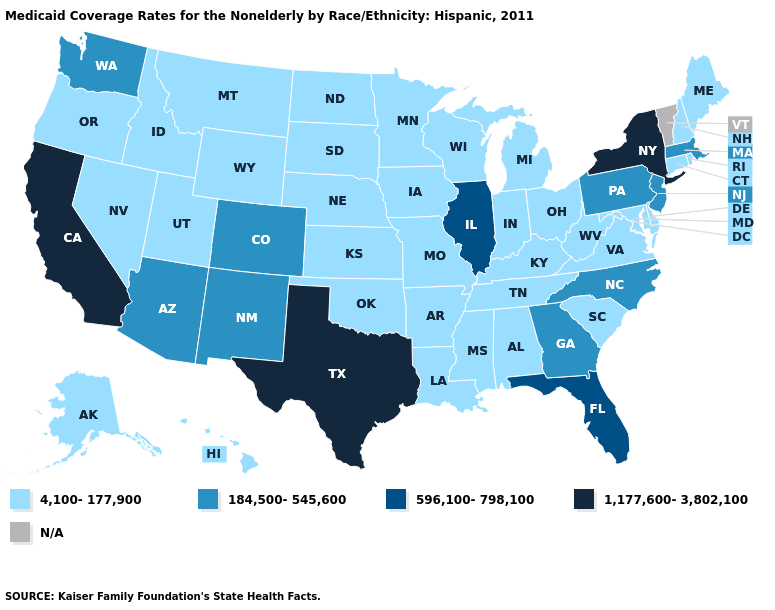Name the states that have a value in the range 4,100-177,900?
Keep it brief. Alabama, Alaska, Arkansas, Connecticut, Delaware, Hawaii, Idaho, Indiana, Iowa, Kansas, Kentucky, Louisiana, Maine, Maryland, Michigan, Minnesota, Mississippi, Missouri, Montana, Nebraska, Nevada, New Hampshire, North Dakota, Ohio, Oklahoma, Oregon, Rhode Island, South Carolina, South Dakota, Tennessee, Utah, Virginia, West Virginia, Wisconsin, Wyoming. Among the states that border Nevada , does Utah have the highest value?
Keep it brief. No. What is the highest value in states that border Pennsylvania?
Quick response, please. 1,177,600-3,802,100. Does Mississippi have the lowest value in the USA?
Quick response, please. Yes. Does North Carolina have the lowest value in the USA?
Quick response, please. No. Which states have the lowest value in the MidWest?
Quick response, please. Indiana, Iowa, Kansas, Michigan, Minnesota, Missouri, Nebraska, North Dakota, Ohio, South Dakota, Wisconsin. What is the highest value in the Northeast ?
Concise answer only. 1,177,600-3,802,100. Does Illinois have the lowest value in the USA?
Give a very brief answer. No. What is the highest value in the West ?
Keep it brief. 1,177,600-3,802,100. Does the first symbol in the legend represent the smallest category?
Be succinct. Yes. Name the states that have a value in the range 1,177,600-3,802,100?
Give a very brief answer. California, New York, Texas. Does New York have the highest value in the USA?
Short answer required. Yes. Name the states that have a value in the range 184,500-545,600?
Write a very short answer. Arizona, Colorado, Georgia, Massachusetts, New Jersey, New Mexico, North Carolina, Pennsylvania, Washington. What is the highest value in the USA?
Quick response, please. 1,177,600-3,802,100. 